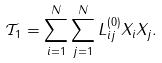<formula> <loc_0><loc_0><loc_500><loc_500>\mathcal { T } _ { 1 } = \sum _ { i = 1 } ^ { N } \sum _ { j = 1 } ^ { N } L ^ { ( 0 ) } _ { i j } X _ { i } X _ { j } .</formula> 